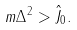Convert formula to latex. <formula><loc_0><loc_0><loc_500><loc_500>m \Delta ^ { 2 } > \hat { J } _ { 0 } .</formula> 